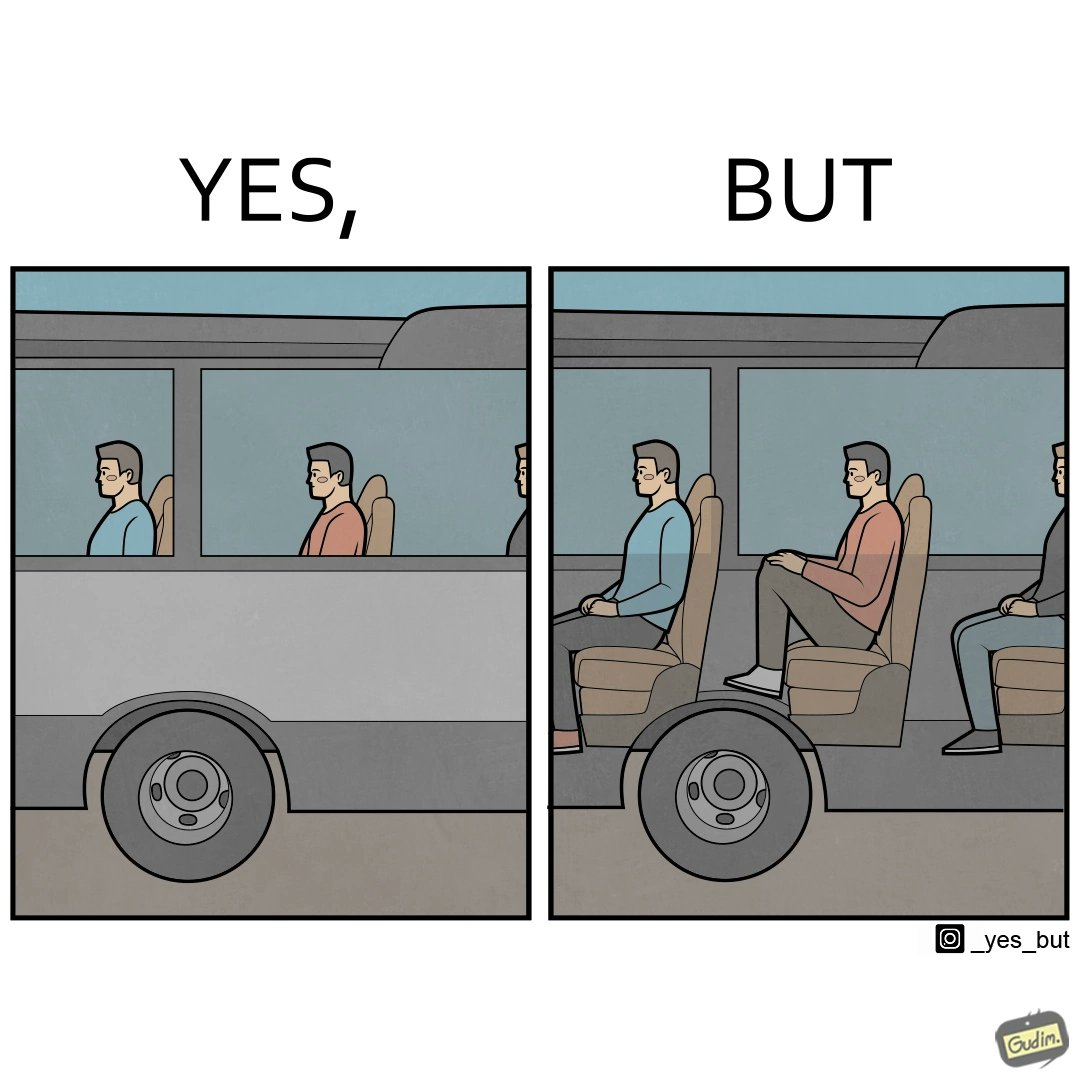Does this image contain satire or humor? Yes, this image is satirical. 